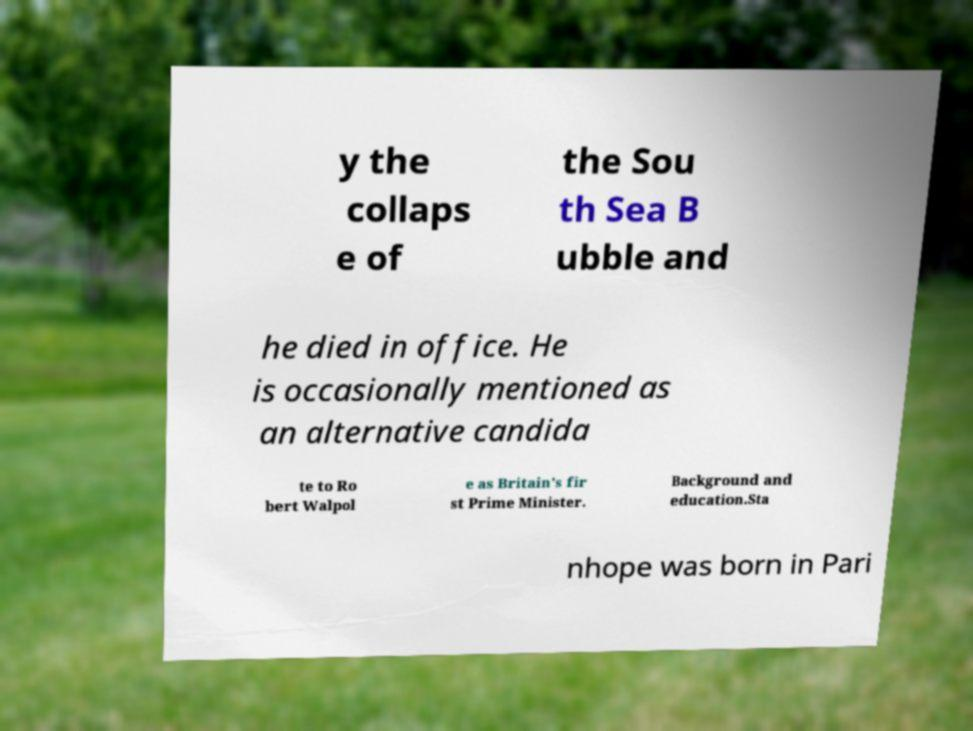Could you extract and type out the text from this image? y the collaps e of the Sou th Sea B ubble and he died in office. He is occasionally mentioned as an alternative candida te to Ro bert Walpol e as Britain's fir st Prime Minister. Background and education.Sta nhope was born in Pari 